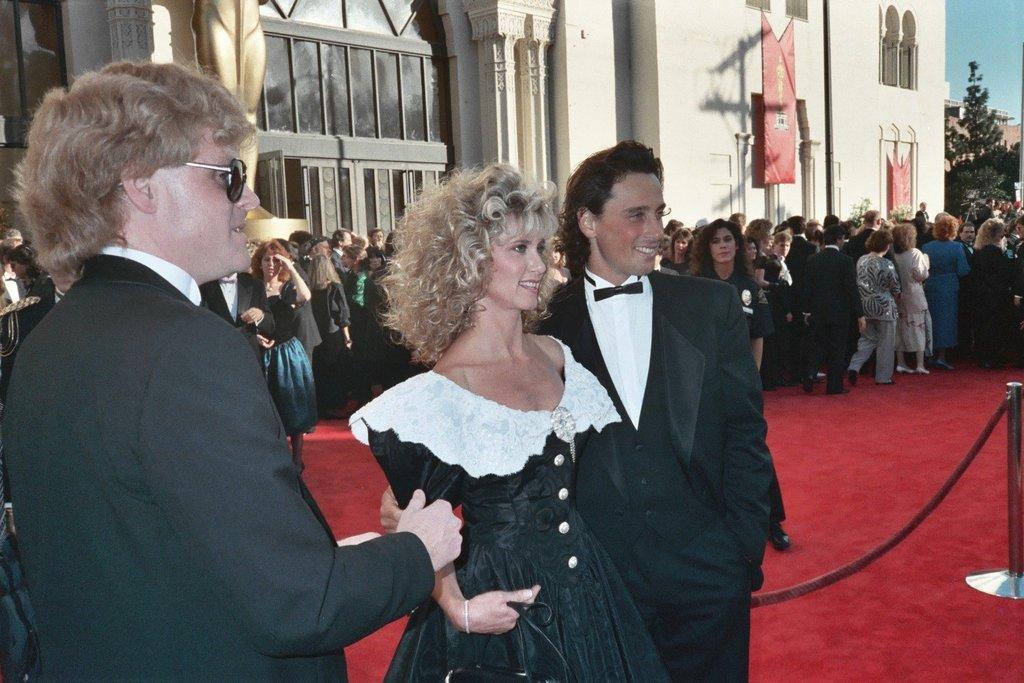Could you give a brief overview of what you see in this image? In this image we can see a few people standing, we can see the stainless steel barrier, behind we can see the building and windows, trees, we can see the sky. 